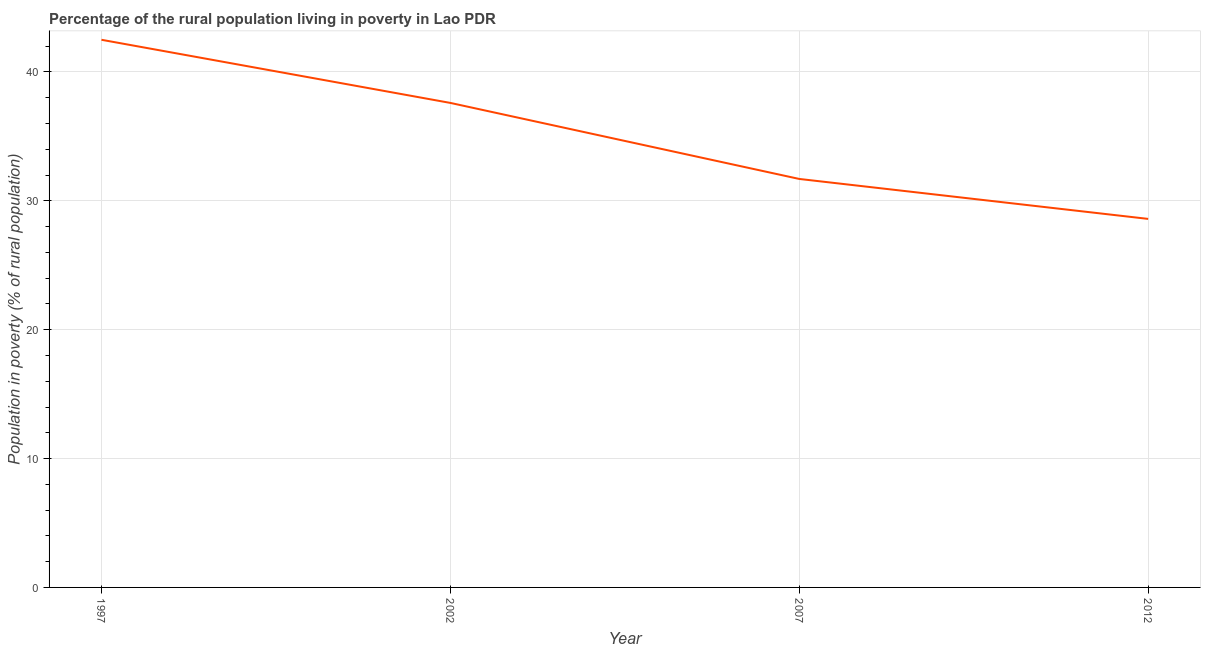What is the percentage of rural population living below poverty line in 1997?
Make the answer very short. 42.5. Across all years, what is the maximum percentage of rural population living below poverty line?
Your answer should be very brief. 42.5. Across all years, what is the minimum percentage of rural population living below poverty line?
Provide a short and direct response. 28.6. In which year was the percentage of rural population living below poverty line maximum?
Provide a short and direct response. 1997. In which year was the percentage of rural population living below poverty line minimum?
Provide a succinct answer. 2012. What is the sum of the percentage of rural population living below poverty line?
Your answer should be very brief. 140.4. What is the difference between the percentage of rural population living below poverty line in 1997 and 2002?
Your answer should be compact. 4.9. What is the average percentage of rural population living below poverty line per year?
Make the answer very short. 35.1. What is the median percentage of rural population living below poverty line?
Make the answer very short. 34.65. In how many years, is the percentage of rural population living below poverty line greater than 26 %?
Offer a very short reply. 4. Do a majority of the years between 2012 and 2007 (inclusive) have percentage of rural population living below poverty line greater than 30 %?
Offer a very short reply. No. What is the ratio of the percentage of rural population living below poverty line in 1997 to that in 2002?
Give a very brief answer. 1.13. Is the percentage of rural population living below poverty line in 2002 less than that in 2012?
Keep it short and to the point. No. What is the difference between the highest and the second highest percentage of rural population living below poverty line?
Provide a succinct answer. 4.9. Is the sum of the percentage of rural population living below poverty line in 2007 and 2012 greater than the maximum percentage of rural population living below poverty line across all years?
Make the answer very short. Yes. What is the difference between the highest and the lowest percentage of rural population living below poverty line?
Give a very brief answer. 13.9. Does the percentage of rural population living below poverty line monotonically increase over the years?
Keep it short and to the point. No. How many lines are there?
Keep it short and to the point. 1. How many years are there in the graph?
Your answer should be compact. 4. Are the values on the major ticks of Y-axis written in scientific E-notation?
Keep it short and to the point. No. Does the graph contain grids?
Keep it short and to the point. Yes. What is the title of the graph?
Ensure brevity in your answer.  Percentage of the rural population living in poverty in Lao PDR. What is the label or title of the X-axis?
Make the answer very short. Year. What is the label or title of the Y-axis?
Make the answer very short. Population in poverty (% of rural population). What is the Population in poverty (% of rural population) of 1997?
Offer a terse response. 42.5. What is the Population in poverty (% of rural population) in 2002?
Offer a very short reply. 37.6. What is the Population in poverty (% of rural population) of 2007?
Offer a terse response. 31.7. What is the Population in poverty (% of rural population) of 2012?
Offer a very short reply. 28.6. What is the difference between the Population in poverty (% of rural population) in 1997 and 2012?
Your response must be concise. 13.9. What is the difference between the Population in poverty (% of rural population) in 2002 and 2007?
Your answer should be compact. 5.9. What is the difference between the Population in poverty (% of rural population) in 2007 and 2012?
Your answer should be compact. 3.1. What is the ratio of the Population in poverty (% of rural population) in 1997 to that in 2002?
Offer a terse response. 1.13. What is the ratio of the Population in poverty (% of rural population) in 1997 to that in 2007?
Your answer should be very brief. 1.34. What is the ratio of the Population in poverty (% of rural population) in 1997 to that in 2012?
Give a very brief answer. 1.49. What is the ratio of the Population in poverty (% of rural population) in 2002 to that in 2007?
Offer a terse response. 1.19. What is the ratio of the Population in poverty (% of rural population) in 2002 to that in 2012?
Provide a succinct answer. 1.31. What is the ratio of the Population in poverty (% of rural population) in 2007 to that in 2012?
Provide a succinct answer. 1.11. 